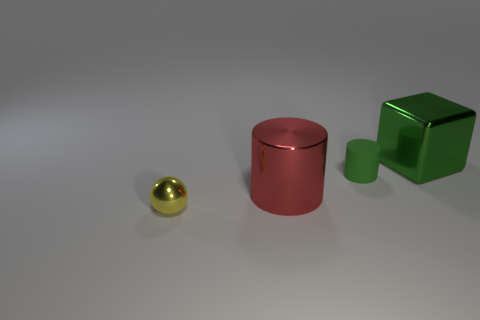How would you describe the texture of the surfaces on which the objects are placed? The surfaces appear to be quite smooth with a subtle reflective property, suggesting a polished concrete floor or perhaps a fine matte finish on a solid, even material. This provides a clean, minimalist background that contrasts nicely with the objects resting on it. 